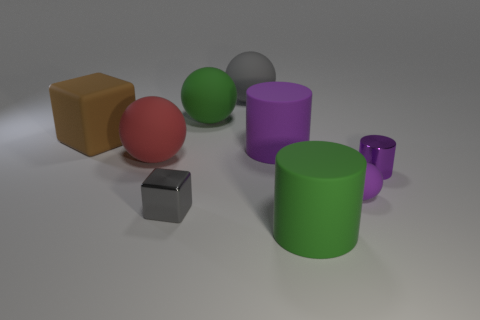Add 1 rubber objects. How many objects exist? 10 Subtract all cylinders. How many objects are left? 6 Add 9 red things. How many red things are left? 10 Add 7 tiny gray things. How many tiny gray things exist? 8 Subtract 0 red blocks. How many objects are left? 9 Subtract all green things. Subtract all blue objects. How many objects are left? 7 